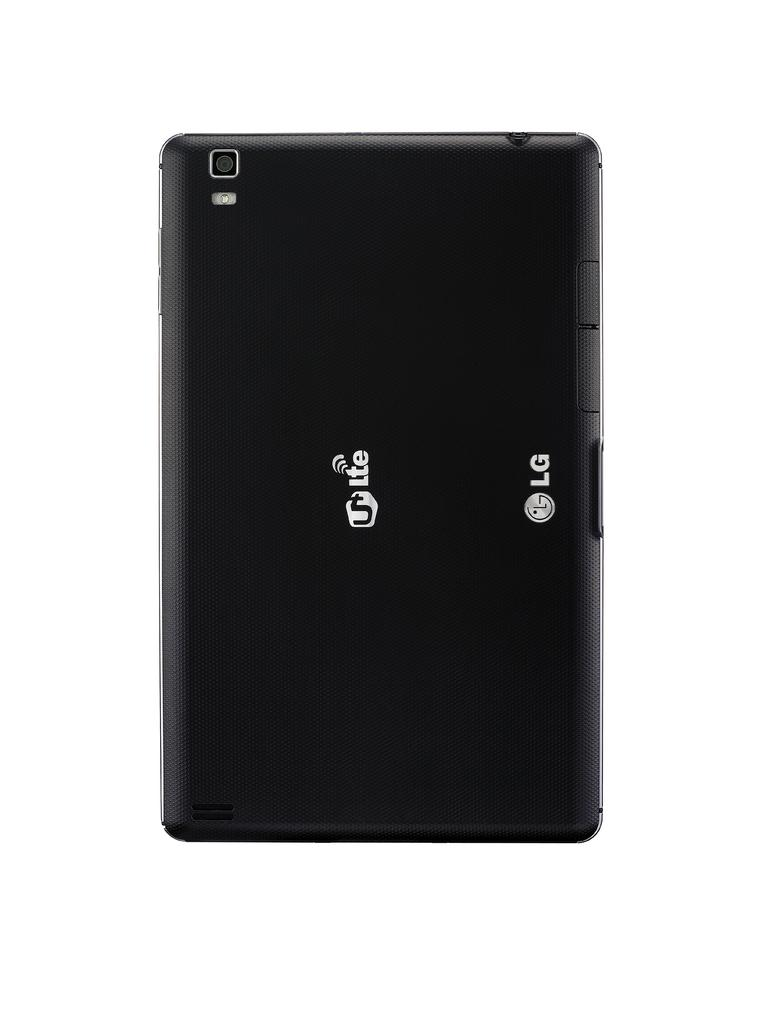<image>
Offer a succinct explanation of the picture presented. The back side of an LG phone is black and has a camera lens at the top. 